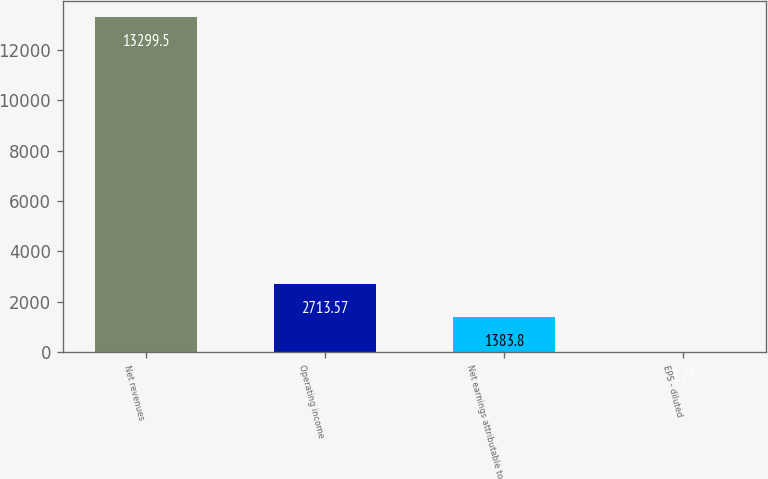<chart> <loc_0><loc_0><loc_500><loc_500><bar_chart><fcel>Net revenues<fcel>Operating income<fcel>Net earnings attributable to<fcel>EPS - diluted<nl><fcel>13299.5<fcel>2713.57<fcel>1383.8<fcel>1.79<nl></chart> 